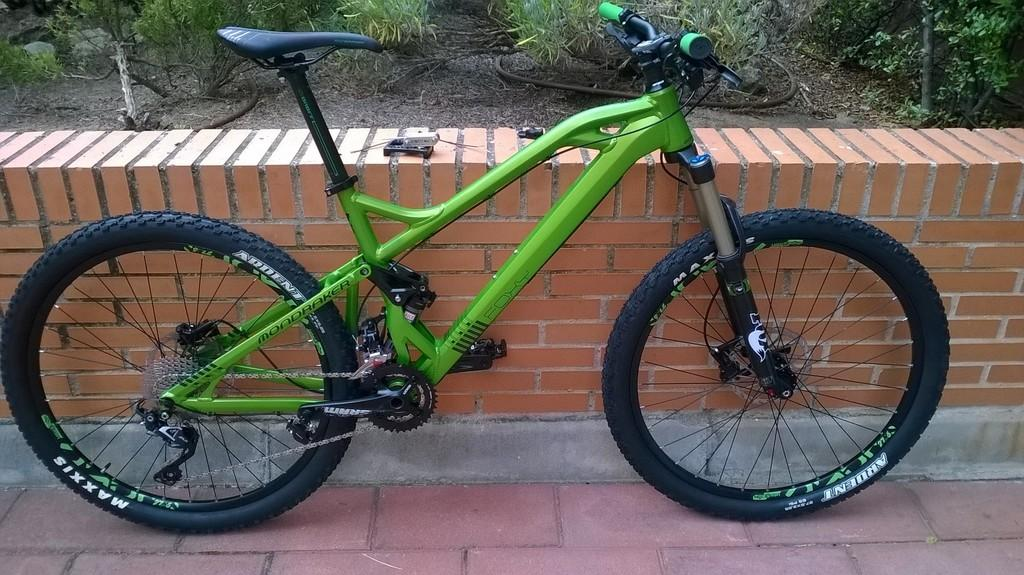What is the main object in the picture? There is a bicycle in the picture. What else can be seen in the picture besides the bicycle? There is a small brick wall and plants in the picture. What type of fiction is the bicycle reading in the picture? There is no indication in the image that the bicycle is reading any fiction, as bicycles do not have the ability to read. 